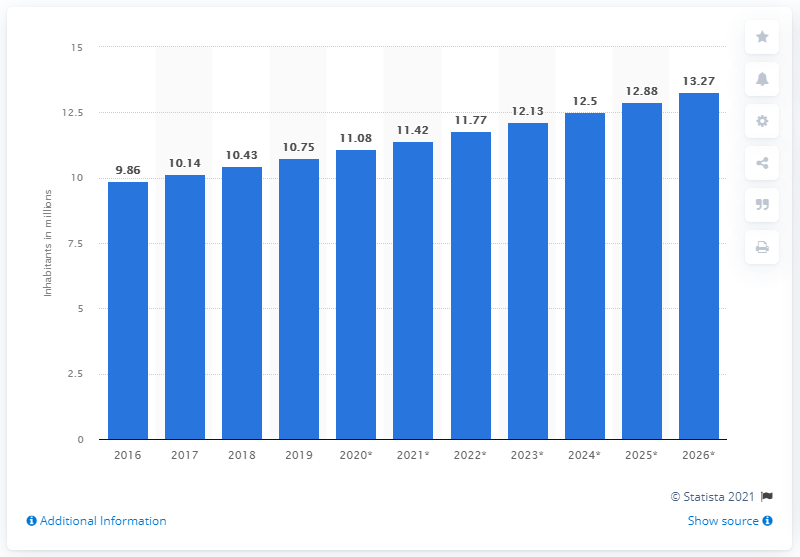Highlight a few significant elements in this photo. In 2019, the population of the UAE was approximately 10.75 million. 